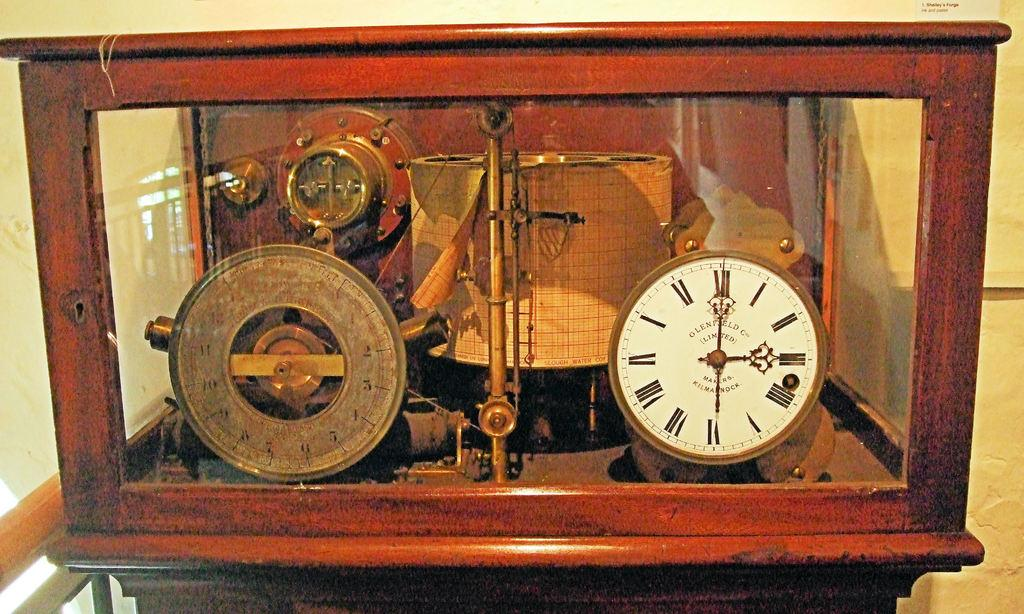<image>
Write a terse but informative summary of the picture. An old clock and a new clock are in a case, and the new one displays a time of 3:00. 